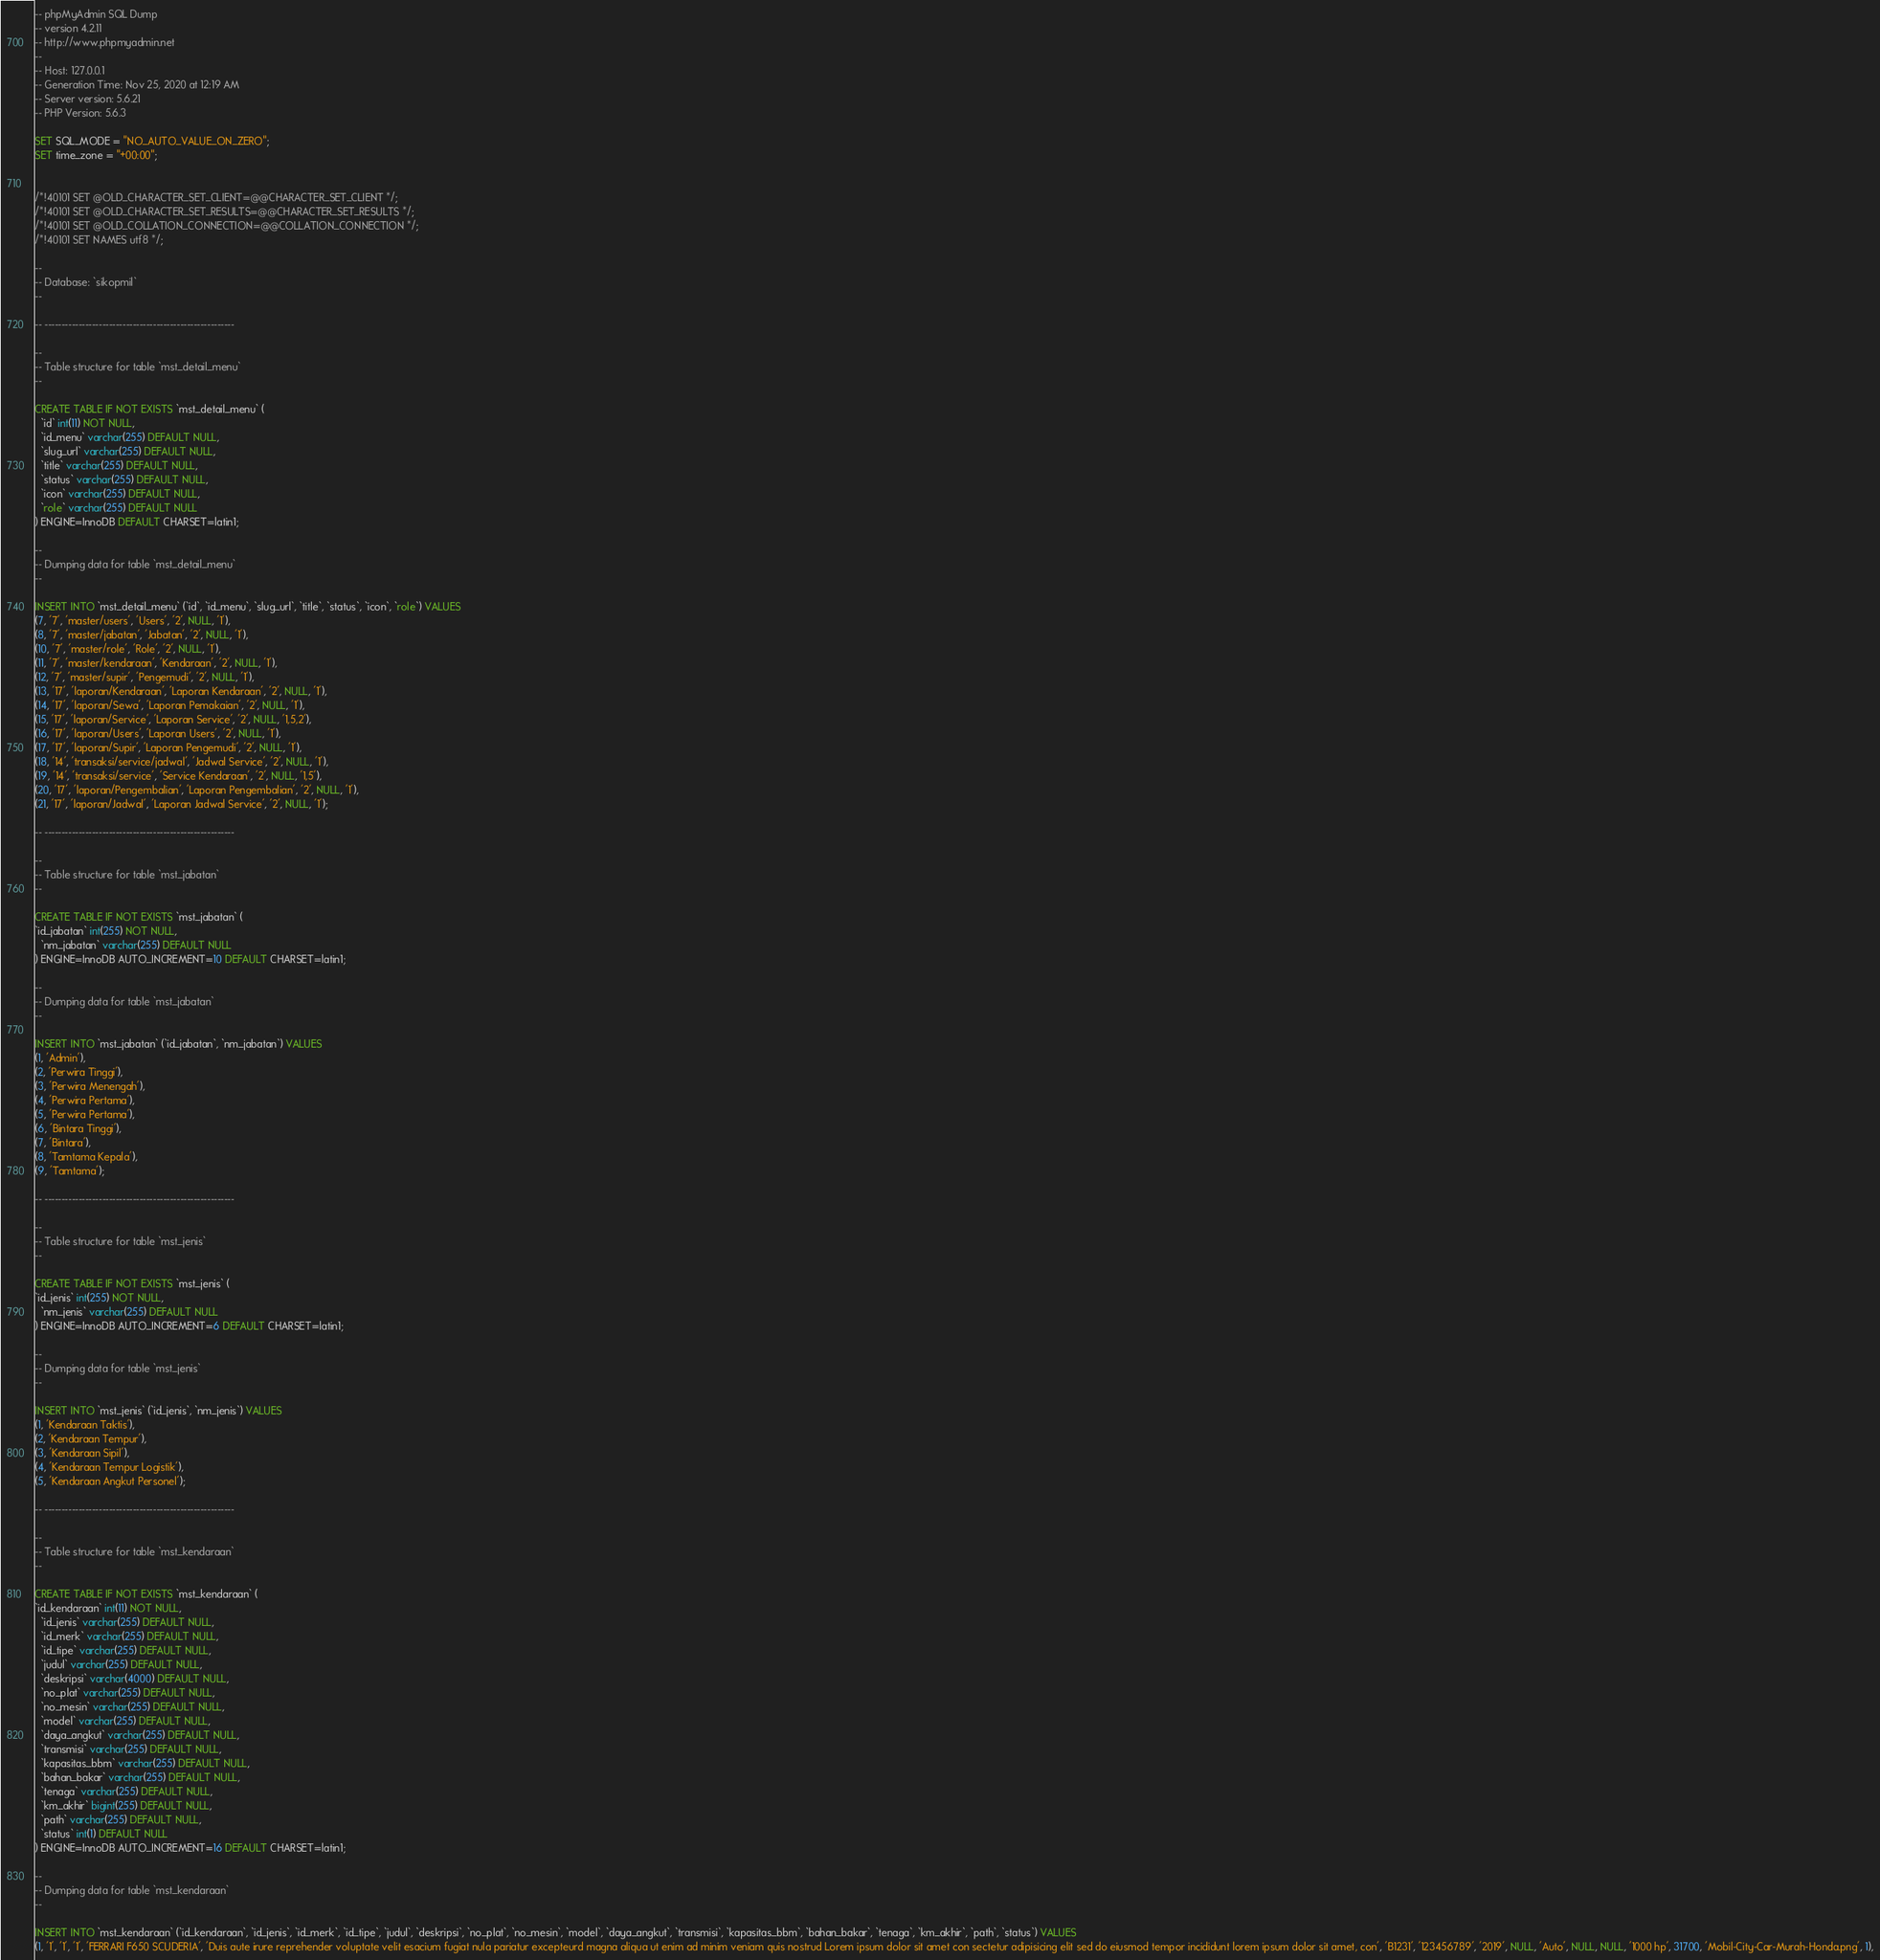Convert code to text. <code><loc_0><loc_0><loc_500><loc_500><_SQL_>-- phpMyAdmin SQL Dump
-- version 4.2.11
-- http://www.phpmyadmin.net
--
-- Host: 127.0.0.1
-- Generation Time: Nov 25, 2020 at 12:19 AM
-- Server version: 5.6.21
-- PHP Version: 5.6.3

SET SQL_MODE = "NO_AUTO_VALUE_ON_ZERO";
SET time_zone = "+00:00";


/*!40101 SET @OLD_CHARACTER_SET_CLIENT=@@CHARACTER_SET_CLIENT */;
/*!40101 SET @OLD_CHARACTER_SET_RESULTS=@@CHARACTER_SET_RESULTS */;
/*!40101 SET @OLD_COLLATION_CONNECTION=@@COLLATION_CONNECTION */;
/*!40101 SET NAMES utf8 */;

--
-- Database: `sikopmil`
--

-- --------------------------------------------------------

--
-- Table structure for table `mst_detail_menu`
--

CREATE TABLE IF NOT EXISTS `mst_detail_menu` (
  `id` int(11) NOT NULL,
  `id_menu` varchar(255) DEFAULT NULL,
  `slug_url` varchar(255) DEFAULT NULL,
  `title` varchar(255) DEFAULT NULL,
  `status` varchar(255) DEFAULT NULL,
  `icon` varchar(255) DEFAULT NULL,
  `role` varchar(255) DEFAULT NULL
) ENGINE=InnoDB DEFAULT CHARSET=latin1;

--
-- Dumping data for table `mst_detail_menu`
--

INSERT INTO `mst_detail_menu` (`id`, `id_menu`, `slug_url`, `title`, `status`, `icon`, `role`) VALUES
(7, '7', 'master/users', 'Users', '2', NULL, '1'),
(8, '7', 'master/jabatan', 'Jabatan', '2', NULL, '1'),
(10, '7', 'master/role', 'Role', '2', NULL, '1'),
(11, '7', 'master/kendaraan', 'Kendaraan', '2', NULL, '1'),
(12, '7', 'master/supir', 'Pengemudi', '2', NULL, '1'),
(13, '17', 'laporan/Kendaraan', 'Laporan Kendaraan', '2', NULL, '1'),
(14, '17', 'laporan/Sewa', 'Laporan Pemakaian', '2', NULL, '1'),
(15, '17', 'laporan/Service', 'Laporan Service', '2', NULL, '1,5,2'),
(16, '17', 'laporan/Users', 'Laporan Users', '2', NULL, '1'),
(17, '17', 'laporan/Supir', 'Laporan Pengemudi', '2', NULL, '1'),
(18, '14', 'transaksi/service/jadwal', 'Jadwal Service', '2', NULL, '1'),
(19, '14', 'transaksi/service', 'Service Kendaraan', '2', NULL, '1,5'),
(20, '17', 'laporan/Pengembalian', 'Laporan Pengembalian', '2', NULL, '1'),
(21, '17', 'laporan/Jadwal', 'Laporan Jadwal Service', '2', NULL, '1');

-- --------------------------------------------------------

--
-- Table structure for table `mst_jabatan`
--

CREATE TABLE IF NOT EXISTS `mst_jabatan` (
`id_jabatan` int(255) NOT NULL,
  `nm_jabatan` varchar(255) DEFAULT NULL
) ENGINE=InnoDB AUTO_INCREMENT=10 DEFAULT CHARSET=latin1;

--
-- Dumping data for table `mst_jabatan`
--

INSERT INTO `mst_jabatan` (`id_jabatan`, `nm_jabatan`) VALUES
(1, 'Admin'),
(2, 'Perwira Tinggi'),
(3, 'Perwira Menengah'),
(4, 'Perwira Pertama'),
(5, 'Perwira Pertama'),
(6, 'Bintara Tinggi'),
(7, 'Bintara'),
(8, 'Tamtama Kepala'),
(9, 'Tamtama');

-- --------------------------------------------------------

--
-- Table structure for table `mst_jenis`
--

CREATE TABLE IF NOT EXISTS `mst_jenis` (
`id_jenis` int(255) NOT NULL,
  `nm_jenis` varchar(255) DEFAULT NULL
) ENGINE=InnoDB AUTO_INCREMENT=6 DEFAULT CHARSET=latin1;

--
-- Dumping data for table `mst_jenis`
--

INSERT INTO `mst_jenis` (`id_jenis`, `nm_jenis`) VALUES
(1, 'Kendaraan Taktis'),
(2, 'Kendaraan Tempur'),
(3, 'Kendaraan Sipil'),
(4, 'Kendaraan Tempur Logistik'),
(5, 'Kendaraan Angkut Personel');

-- --------------------------------------------------------

--
-- Table structure for table `mst_kendaraan`
--

CREATE TABLE IF NOT EXISTS `mst_kendaraan` (
`id_kendaraan` int(11) NOT NULL,
  `id_jenis` varchar(255) DEFAULT NULL,
  `id_merk` varchar(255) DEFAULT NULL,
  `id_tipe` varchar(255) DEFAULT NULL,
  `judul` varchar(255) DEFAULT NULL,
  `deskripsi` varchar(4000) DEFAULT NULL,
  `no_plat` varchar(255) DEFAULT NULL,
  `no_mesin` varchar(255) DEFAULT NULL,
  `model` varchar(255) DEFAULT NULL,
  `daya_angkut` varchar(255) DEFAULT NULL,
  `transmisi` varchar(255) DEFAULT NULL,
  `kapasitas_bbm` varchar(255) DEFAULT NULL,
  `bahan_bakar` varchar(255) DEFAULT NULL,
  `tenaga` varchar(255) DEFAULT NULL,
  `km_akhir` bigint(255) DEFAULT NULL,
  `path` varchar(255) DEFAULT NULL,
  `status` int(1) DEFAULT NULL
) ENGINE=InnoDB AUTO_INCREMENT=16 DEFAULT CHARSET=latin1;

--
-- Dumping data for table `mst_kendaraan`
--

INSERT INTO `mst_kendaraan` (`id_kendaraan`, `id_jenis`, `id_merk`, `id_tipe`, `judul`, `deskripsi`, `no_plat`, `no_mesin`, `model`, `daya_angkut`, `transmisi`, `kapasitas_bbm`, `bahan_bakar`, `tenaga`, `km_akhir`, `path`, `status`) VALUES
(1, '1', '1', '1', 'FERRARI F650 SCUDERIA', 'Duis aute irure reprehender voluptate velit esacium fugiat nula pariatur excepteurd magna aliqua ut enim ad minim veniam quis nostrud Lorem ipsum dolor sit amet con sectetur adipisicing elit sed do eiusmod tempor incididunt lorem ipsum dolor sit amet, con', 'B1231', '123456789', '2019', NULL, 'Auto', NULL, NULL, '1000 hp', 31700, 'Mobil-City-Car-Murah-Honda.png', 1),</code> 